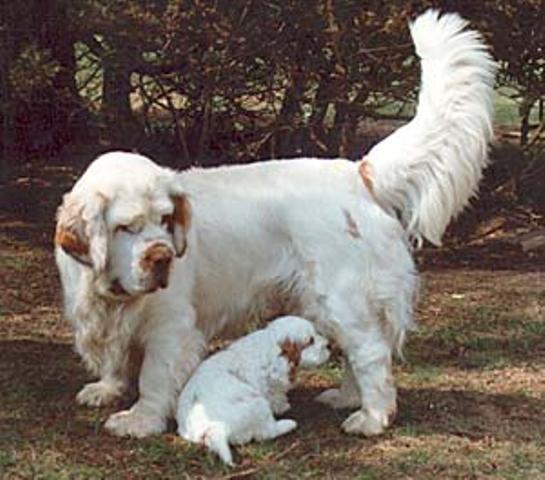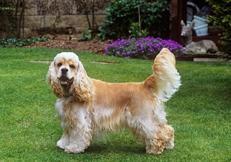The first image is the image on the left, the second image is the image on the right. Evaluate the accuracy of this statement regarding the images: "The dog in the image on the left is on a leash.". Is it true? Answer yes or no. No. The first image is the image on the left, the second image is the image on the right. Assess this claim about the two images: "The left image contains one dog, a chocolate-brown spaniel with a leash extending from its neck.". Correct or not? Answer yes or no. No. 